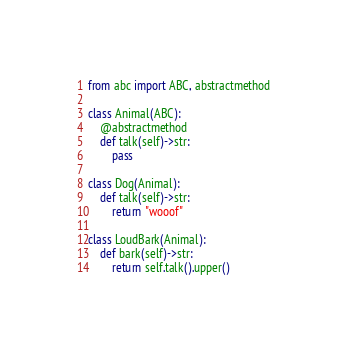Convert code to text. <code><loc_0><loc_0><loc_500><loc_500><_Python_>from abc import ABC, abstractmethod

class Animal(ABC):
    @abstractmethod
    def talk(self)->str:
        pass

class Dog(Animal):
    def talk(self)->str:
        return "wooof"

class LoudBark(Animal):
    def bark(self)->str:
        return self.talk().upper()
</code> 